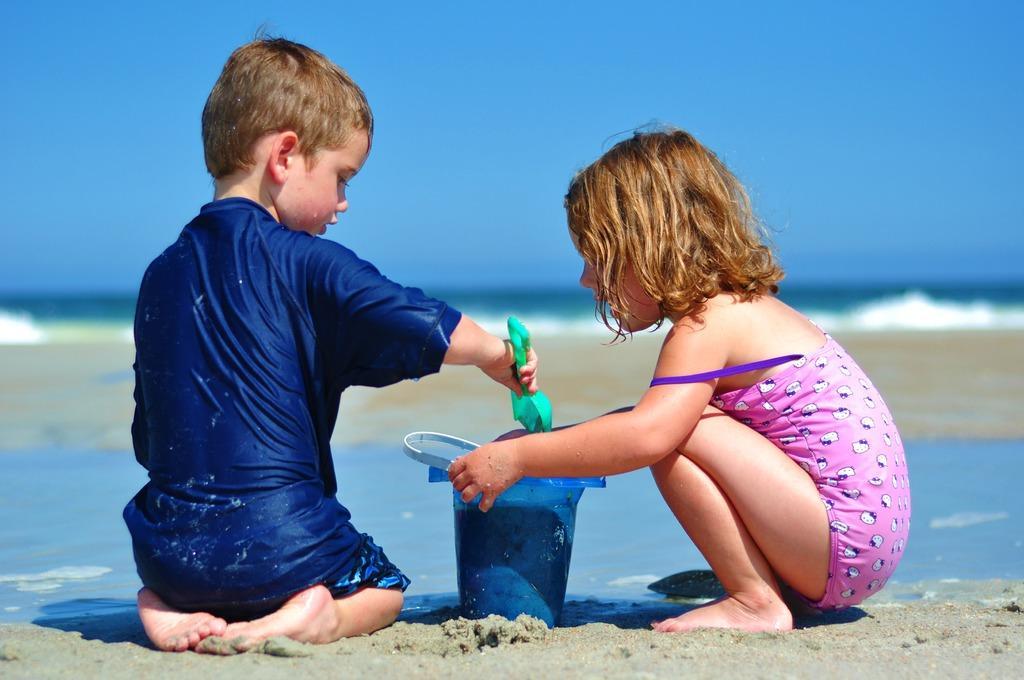Could you give a brief overview of what you see in this image? In the picture we can see a girl and a boy sitting on the sand surface and playing and the boy is wearing blue T-shirt and girl is wearing a pink dress and in the background we can see a sand surface and behind it we can see water and sky. 